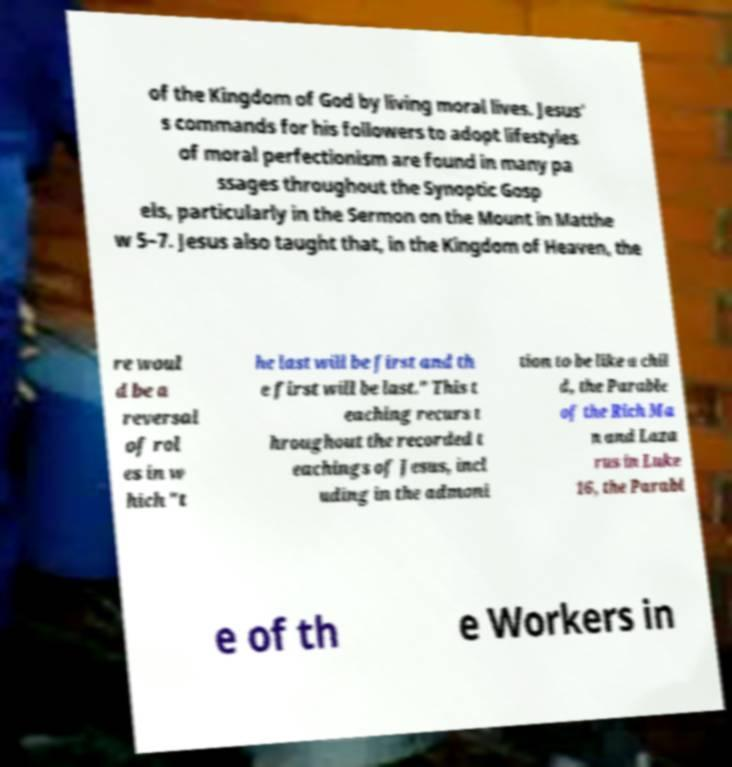There's text embedded in this image that I need extracted. Can you transcribe it verbatim? of the Kingdom of God by living moral lives. Jesus' s commands for his followers to adopt lifestyles of moral perfectionism are found in many pa ssages throughout the Synoptic Gosp els, particularly in the Sermon on the Mount in Matthe w 5–7. Jesus also taught that, in the Kingdom of Heaven, the re woul d be a reversal of rol es in w hich "t he last will be first and th e first will be last." This t eaching recurs t hroughout the recorded t eachings of Jesus, incl uding in the admoni tion to be like a chil d, the Parable of the Rich Ma n and Laza rus in Luke 16, the Parabl e of th e Workers in 